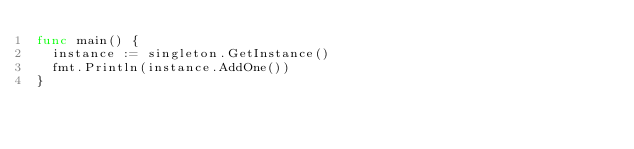<code> <loc_0><loc_0><loc_500><loc_500><_Go_>func main() {
	instance := singleton.GetInstance()
	fmt.Println(instance.AddOne())
}
</code> 